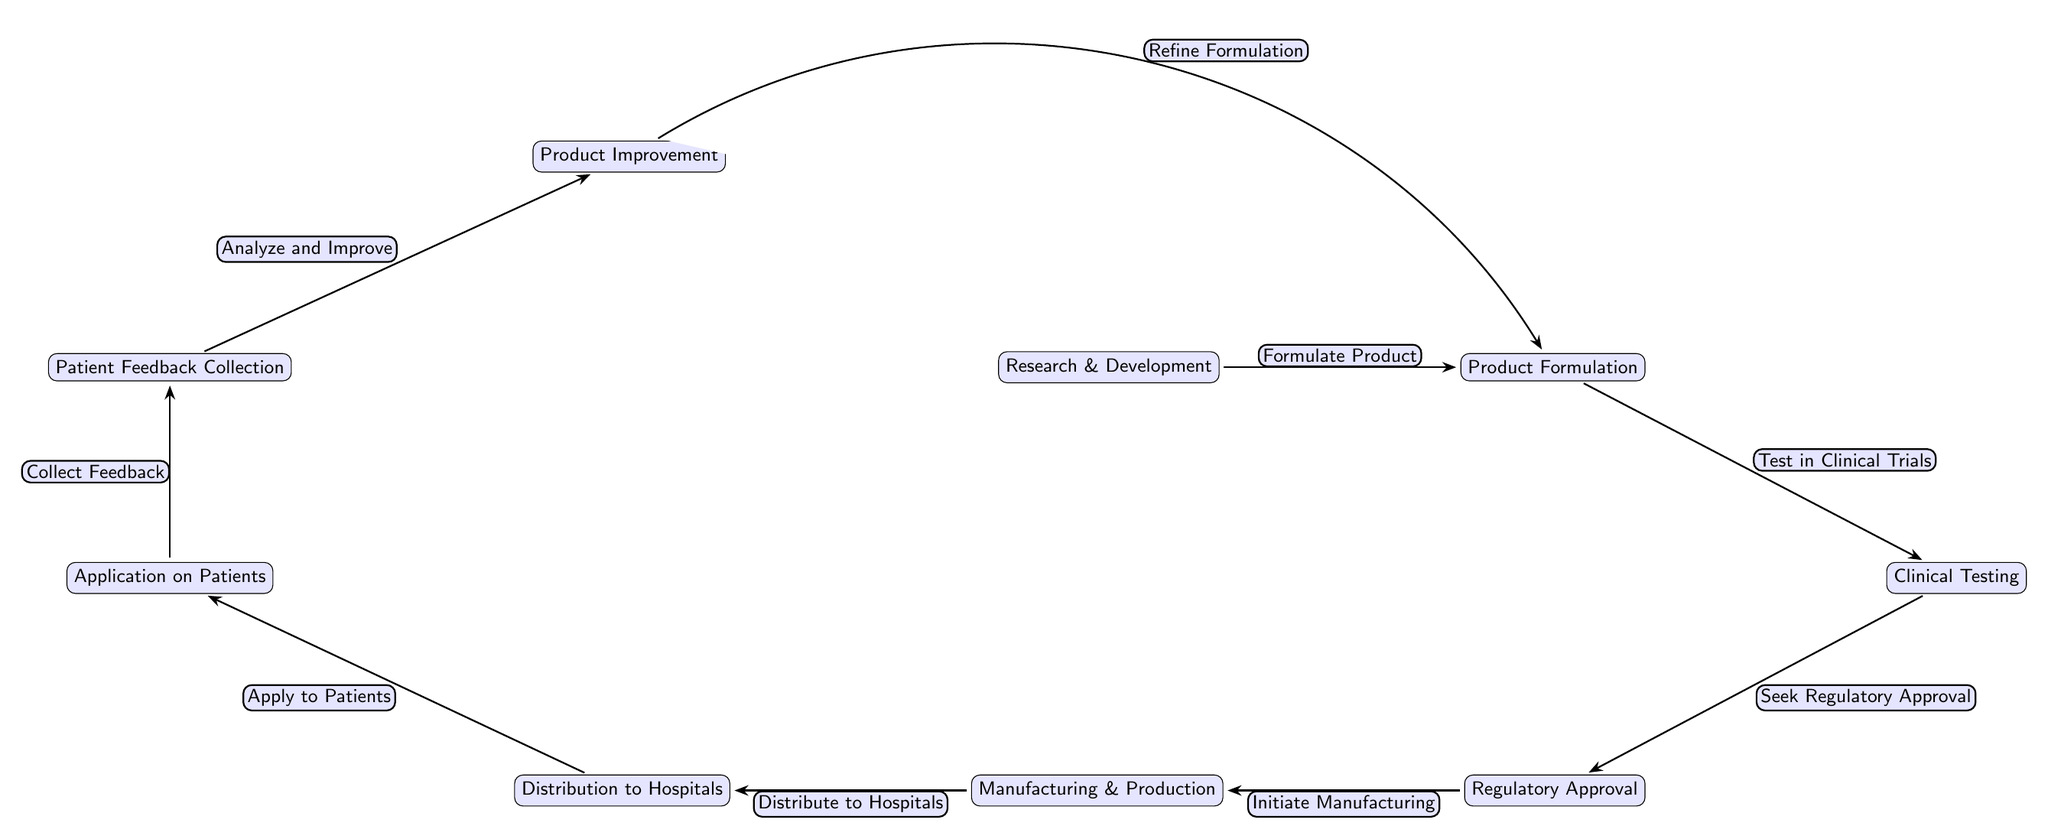What is the first step in the lifecycle of a post-surgical skincare product? The diagram clearly shows that the first step is labeled as "Research & Development," which initiates the entire process.
Answer: Research & Development How many total nodes are present in this food chain diagram? By counting all the distinct steps represented as nodes, including "Research & Development," "Product Formulation," "Clinical Testing," "Regulatory Approval," "Manufacturing & Production," "Distribution to Hospitals," "Application on Patients," "Patient Feedback Collection," and "Product Improvement," we find there are a total of nine nodes.
Answer: Nine What is the step that follows "Clinical Testing"? Looking at the arrows in the diagram, the step that follows "Clinical Testing" is "Regulatory Approval," as shown by the directed edge connecting these nodes.
Answer: Regulatory Approval What action is taken after "Patient Feedback Collection"? According to the diagram, the next action taken after "Patient Feedback Collection" is "Product Improvement," as indicated by the arrow leading from the former to the latter.
Answer: Product Improvement What is the main purpose of the node labeled "Distribution to Hospitals"? The purpose of the node "Distribution to Hospitals" is to convey the product to the healthcare facilities where it will be applied to patients, as indicated by the connecting arrows leading to the subsequent step.
Answer: Distribute to Hospitals Which node is connected directly to both "Clinical Testing" and "Manufacturing & Production"? The node that connects directly to both "Clinical Testing" and "Manufacturing & Production" is "Regulatory Approval," which stands between these two processes in the diagram.
Answer: Regulatory Approval How does the process flow from "Application on Patients" to "Feedback Collection"? The flow from "Application on Patients" to "Feedback Collection" is dictated by the arrow drawn from the former node to the latter, indicating the sequence of events where feedback is gathered following patient care.
Answer: Collect Feedback What improvement action is indicated after "Patient Feedback Collection"? The diagram indicates that the improvement action following "Patient Feedback Collection" is labelled as "Analyze and Improve," which leads us to the next step in the cycle of product development.
Answer: Analyze and Improve What two actions precede the "Clinical Testing" node? The two actions that precede "Clinical Testing" are "Product Formulation," which directly connects to it, and "Research & Development," which is the initial step in the process leading to formulation.
Answer: Formulate Product, Research & Development 